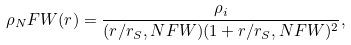Convert formula to latex. <formula><loc_0><loc_0><loc_500><loc_500>\rho _ { N } F W ( r ) = \frac { \rho _ { i } } { ( r / r _ { S } , N F W ) ( 1 + r / r _ { S } , N F W ) ^ { 2 } } ,</formula> 